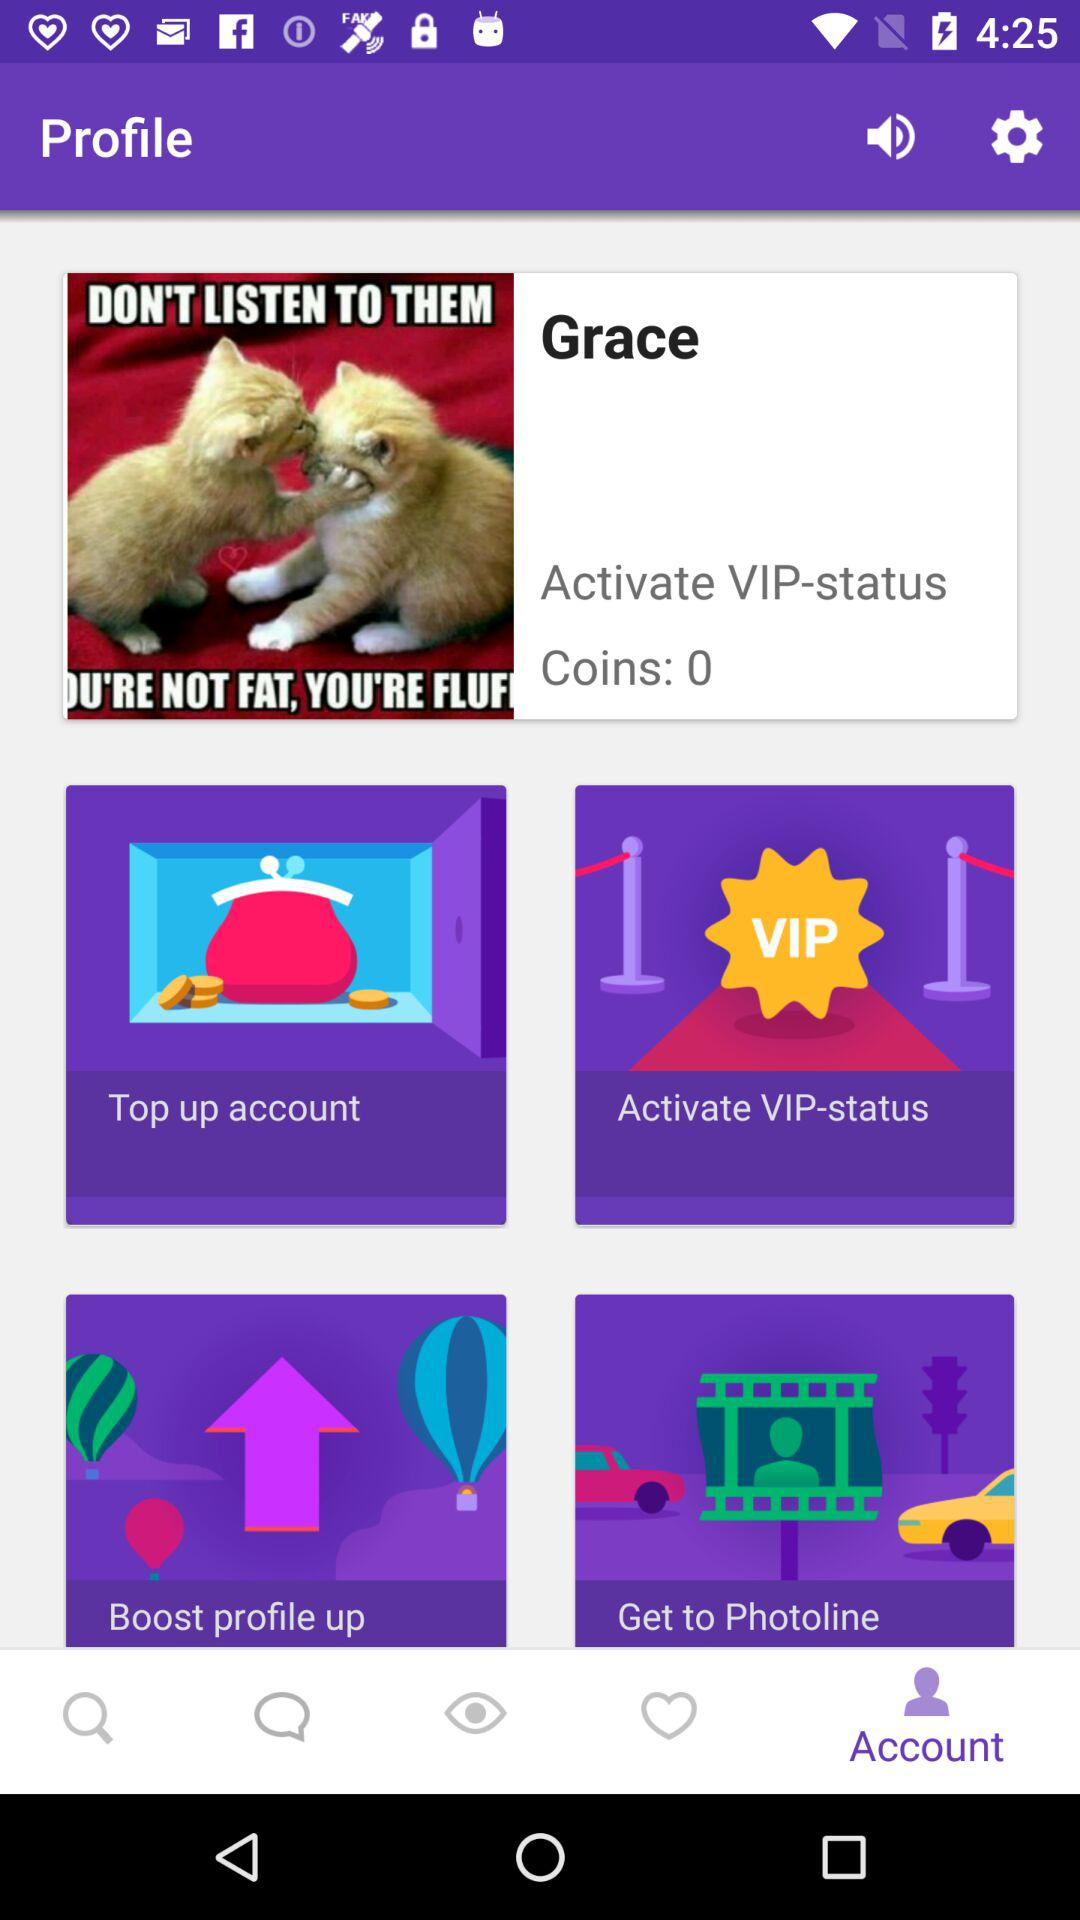What is the user name? The user name is Grace. 